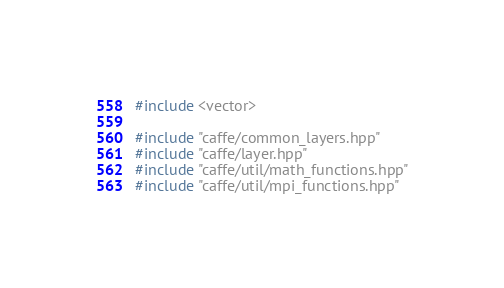<code> <loc_0><loc_0><loc_500><loc_500><_Cuda_>#include <vector>

#include "caffe/common_layers.hpp"
#include "caffe/layer.hpp"
#include "caffe/util/math_functions.hpp"
#include "caffe/util/mpi_functions.hpp"
</code> 